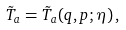Convert formula to latex. <formula><loc_0><loc_0><loc_500><loc_500>\tilde { T } _ { a } = \tilde { T } _ { a } ( q , p ; \eta ) \, ,</formula> 